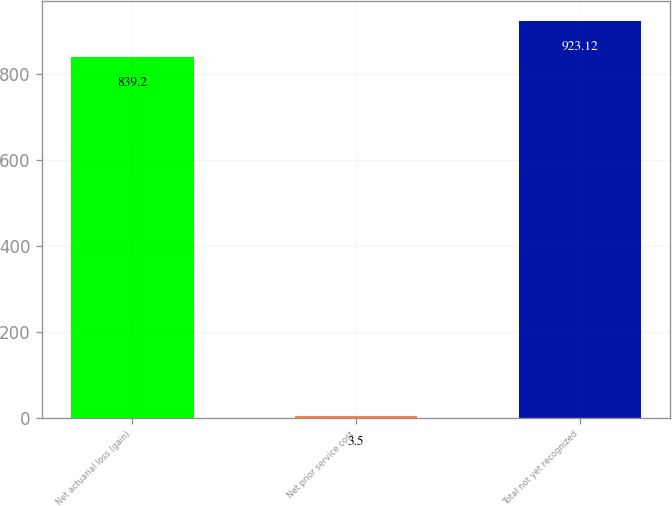Convert chart. <chart><loc_0><loc_0><loc_500><loc_500><bar_chart><fcel>Net actuarial loss (gain)<fcel>Net prior service cost<fcel>Total not yet recognized<nl><fcel>839.2<fcel>3.5<fcel>923.12<nl></chart> 